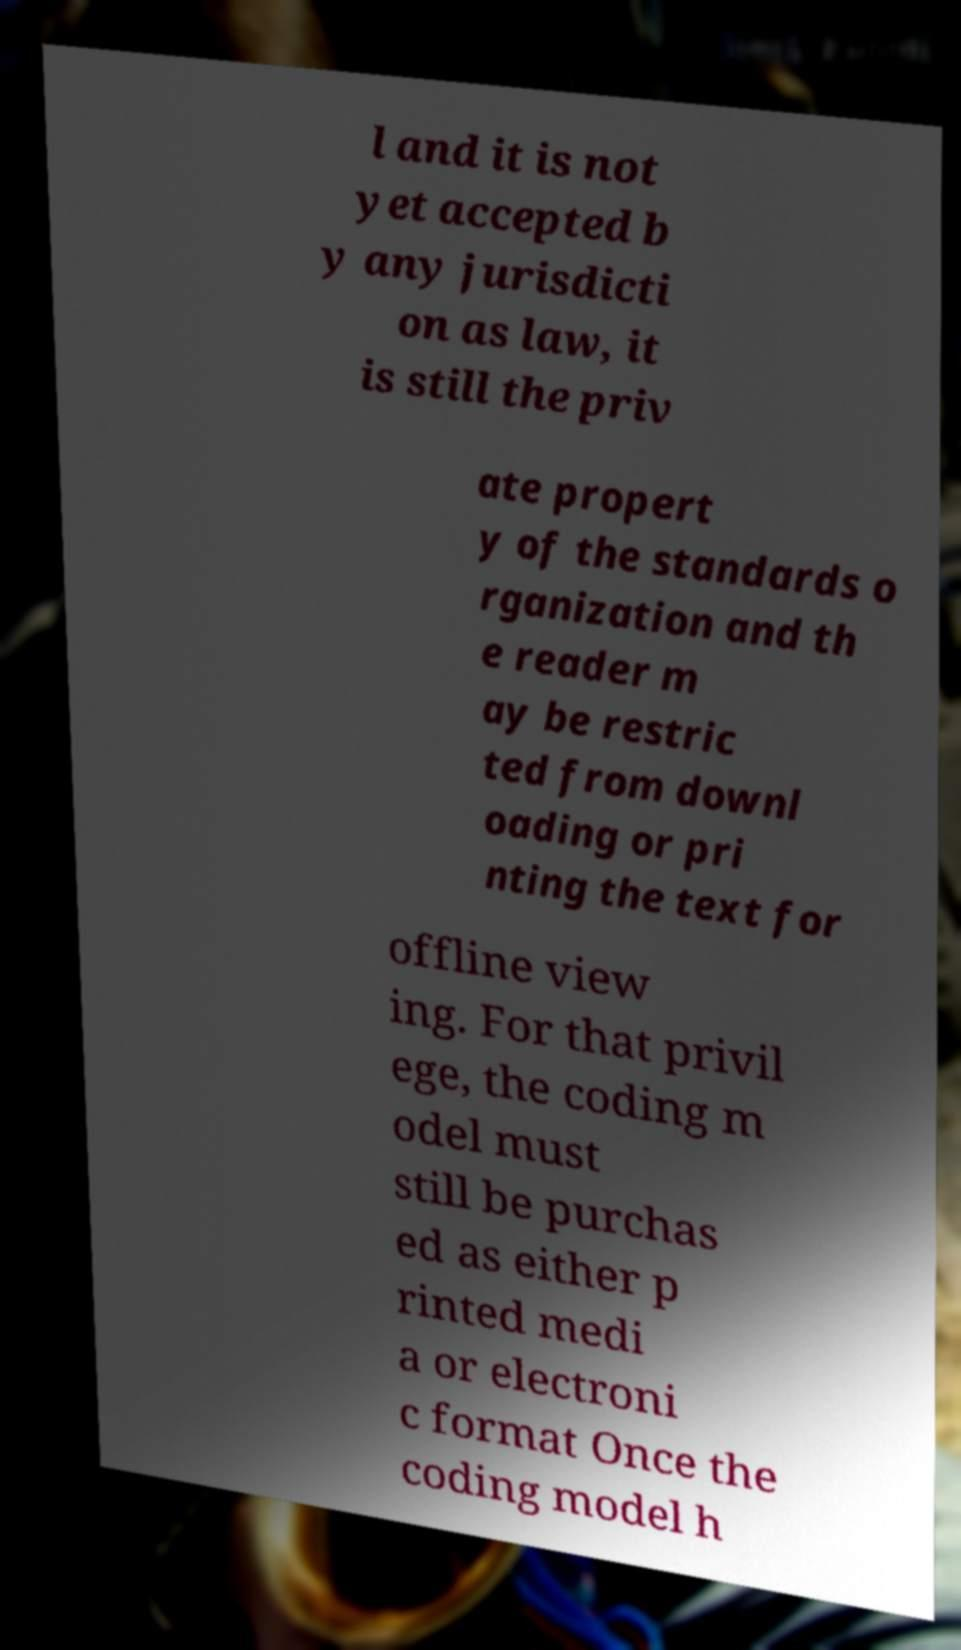There's text embedded in this image that I need extracted. Can you transcribe it verbatim? l and it is not yet accepted b y any jurisdicti on as law, it is still the priv ate propert y of the standards o rganization and th e reader m ay be restric ted from downl oading or pri nting the text for offline view ing. For that privil ege, the coding m odel must still be purchas ed as either p rinted medi a or electroni c format Once the coding model h 